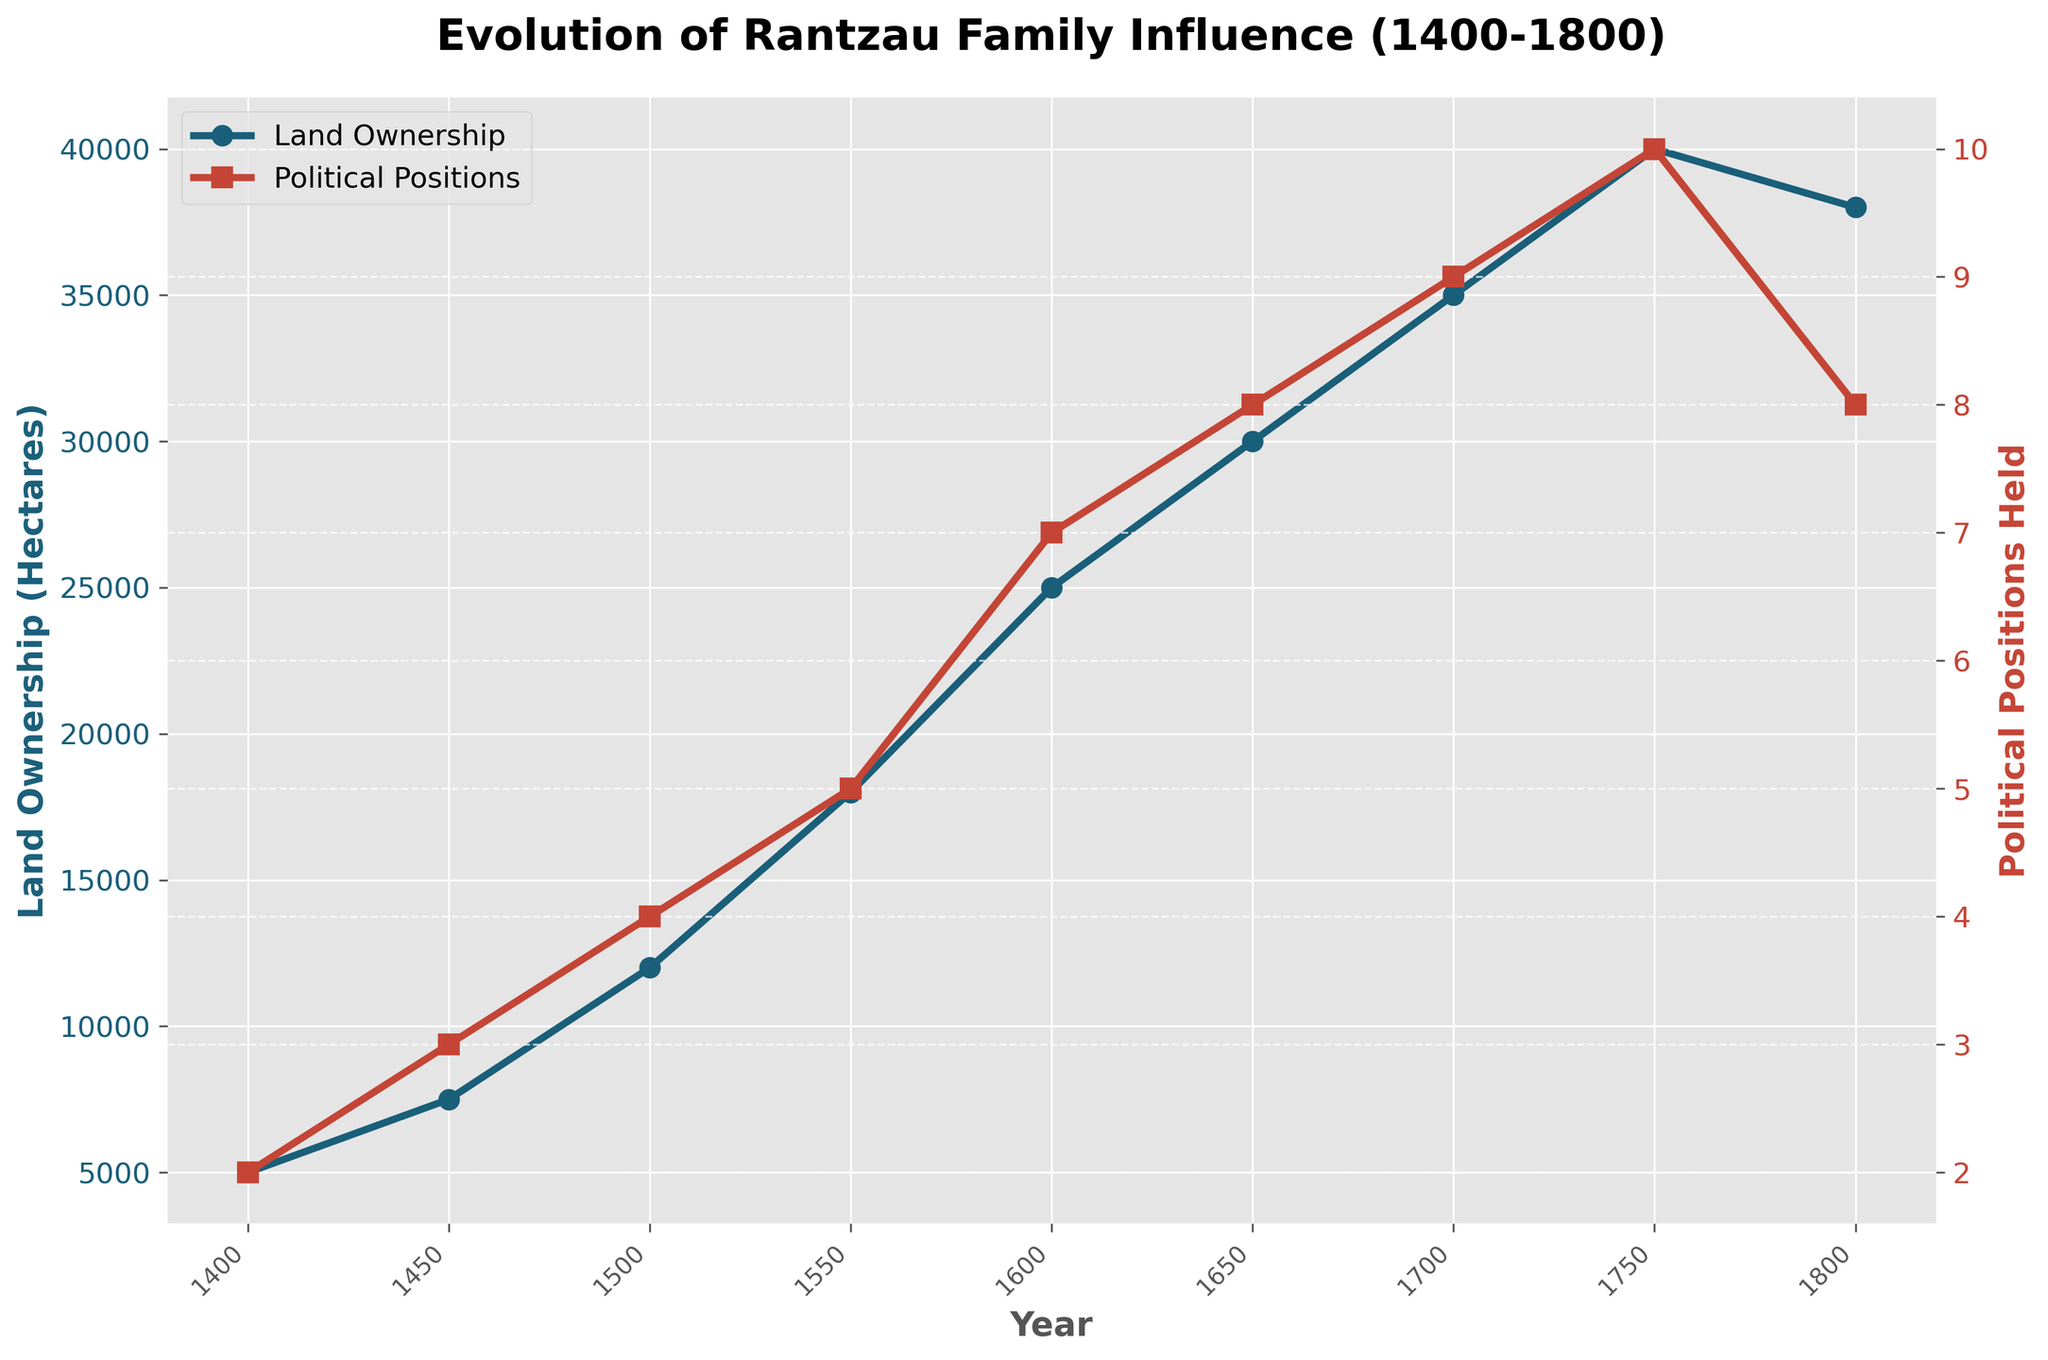What is the trend in land ownership by the Rantzau family from 1400 to 1800? The figure shows the values for land ownership over time, and by looking at the overall shape of the blue line that represents it, one can observe that the land ownership increases consistently until around 1750 and then slightly declines by 1800.
Answer: Increasing until 1750, then slightly declining How did the political positions held by the Rantzau family change between 1700 and 1800? By looking at the red line representing political positions, the number of positions held increased from 9 in 1700 to 10 in 1750, and then decreased to 8 in 1800.
Answer: Increased then decreased What was the peak land ownership of the Rantzau family, and in which year did it occur? The peak is represented by the highest point on the blue line, which occurs at the year 1750, with land ownership reaching 40,000 hectares.
Answer: 40,000 hectares in 1750 Comparing the trends, which increased more rapidly between 1400 and 1450: land ownership or political positions held? By comparing the slopes of the blue and red lines between the years 1400 and 1450, one can see that land ownership increased by 2,500 hectares, while political positions held increased by 1. This indicates that land ownership increased more rapidly.
Answer: Land ownership Was there any period where both land ownership and political positions held remained constant? By observing both the blue line for land ownership and the red line for political positions, there is no period where either of them remains flat, indicating they both changed over the entire duration.
Answer: No On average, how many political positions did the Rantzau family hold from 1400 to 1800? To find the average, sum up all the values of political positions held (2+3+4+5+7+8+9+10+8 = 56) and divide by the number of data points (9). (56/9 ≈ 6.22).
Answer: Approximately 6.22 In which period did political positions held see the largest increase, and what was the change? By observing the red line for the steepest incline, from 1500 to 1550, political positions held increased from 4 to 5, which is a change of 1.
Answer: 1500 to 1550, change of 1 During which century did the land ownership of the Rantzau family grow the most? By visually comparing the increments on the blue line over each century, the largest growth is observed between 1500 and 1600, where land ownership grows from 12,000 to 25,000 hectares, an increase of 13,000 hectares.
Answer: 16th century (1500-1600) What was the land ownership of the Rantzau family in 1650, and how did it compare to their ownership in 1800? Land ownership in 1650 is 30,000 hectares, and in 1800, it is 38,000 hectares. Comparing these values shows there is an increase of 8,000 hectares.
Answer: 30,000 hectares in 1650, increased by 8,000 hectares in 1800 How can you tell which line represents land ownership and which represents political positions held? By looking at the colors and shapes of the markers, the blue line with circular markers represents land ownership, and the red line with square markers represents political positions held, as indicated by the legend on the plot.
Answer: Blue line for land ownership, red line for political positions held 